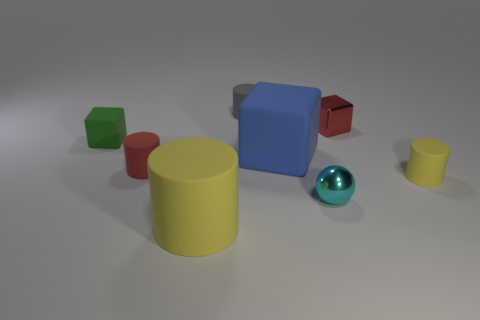Subtract 1 cylinders. How many cylinders are left? 3 Add 2 small red blocks. How many objects exist? 10 Subtract all cubes. How many objects are left? 5 Subtract all rubber objects. Subtract all small gray objects. How many objects are left? 1 Add 8 small red things. How many small red things are left? 10 Add 2 large matte objects. How many large matte objects exist? 4 Subtract 1 green cubes. How many objects are left? 7 